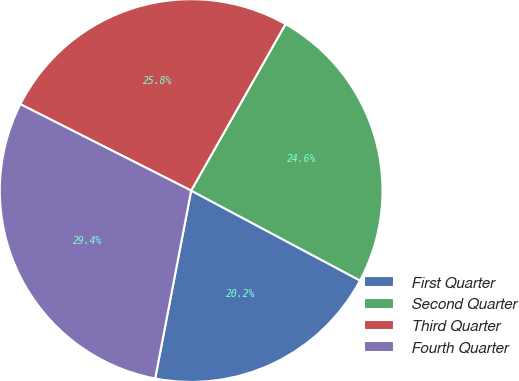Convert chart. <chart><loc_0><loc_0><loc_500><loc_500><pie_chart><fcel>First Quarter<fcel>Second Quarter<fcel>Third Quarter<fcel>Fourth Quarter<nl><fcel>20.22%<fcel>24.58%<fcel>25.75%<fcel>29.44%<nl></chart> 